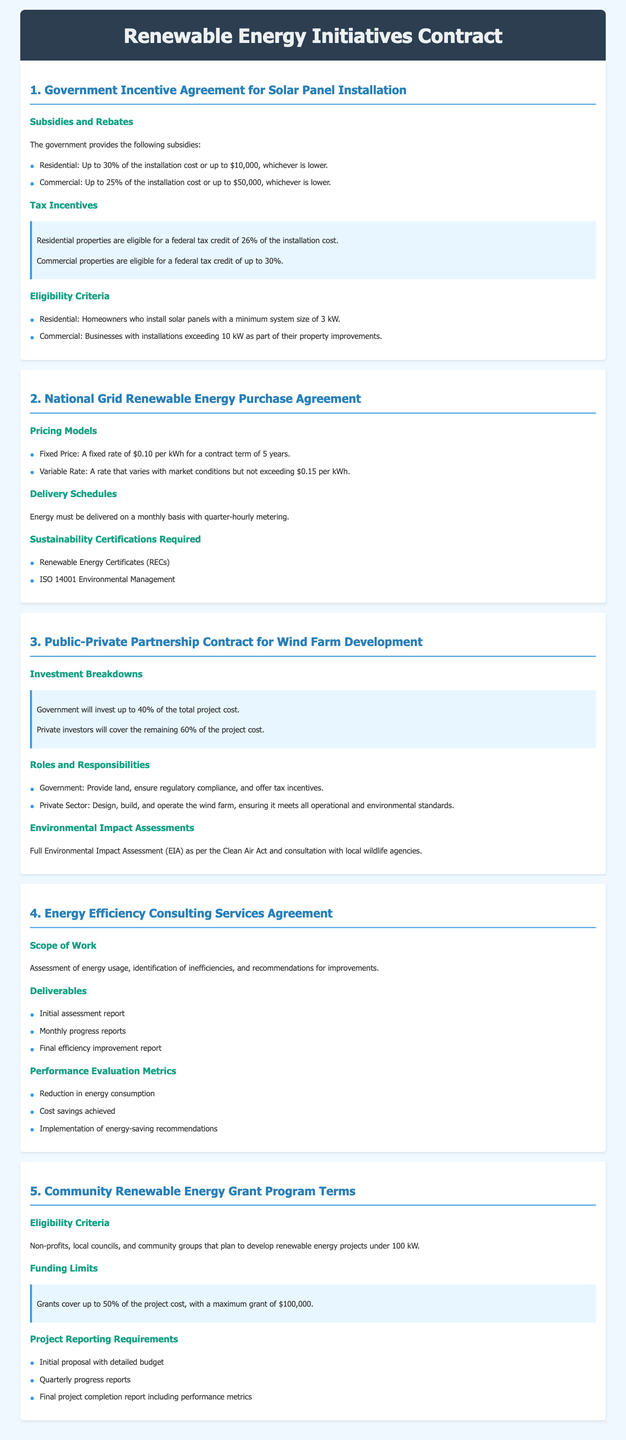What is the maximum subsidy for residential solar panel installation? The maximum subsidy for residential solar panel installation is defined as the lesser of 30% of the installation cost or up to $10,000.
Answer: Up to $10,000 What percentage of project costs will the government cover in the wind farm project? The government will invest up to 40% of the total project cost for the wind farm development.
Answer: 40% What is the fixed price per kWh in the National Grid Renewable Energy Purchase Agreement? The fixed price per kWh is specified for a contract term in the National Grid Renewable Energy Purchase Agreement.
Answer: $0.10 What is the funding limit for the Community Renewable Energy Grant Program? The maximum grant amount provided under the Community Renewable Energy Grant Program is specified in terms of funding limits.
Answer: $100,000 How often must energy be delivered under the National Grid agreement? The delivery frequency of energy is mentioned in the National Grid Renewable Energy Purchase Agreement.
Answer: Monthly What is the minimum system size for residential eligibility for solar panel incentives? The minimum system size required for homeowners to be eligible for solar panel incentives is specified.
Answer: 3 kW What is one required sustainability certification for energy purchase agreements? The requirements for sustainability certifications in the National Grid Renewable Energy Purchase Agreement include specific types of certifications.
Answer: Renewable Energy Certificates (RECs) What is the scope of work included in the Energy Efficiency Consulting Services Agreement? The scope of work outlines the specific tasks included in the Energy Efficiency Consulting Services Agreement.
Answer: Assessment of energy usage, identification of inefficiencies, and recommendations for improvements What type of organizations are eligible for the Community Renewable Energy Grant Program? The eligibility criteria describe the types of organizations allowed to apply for the grant program.
Answer: Non-profits, local councils, and community groups 